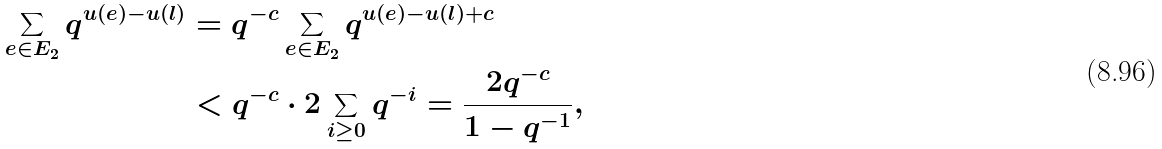Convert formula to latex. <formula><loc_0><loc_0><loc_500><loc_500>\sum _ { e \in E _ { 2 } } q ^ { u ( e ) - u ( l ) } & = q ^ { - c } \sum _ { e \in E _ { 2 } } q ^ { u ( e ) - u ( l ) + c } \\ & < q ^ { - c } \cdot 2 \sum _ { i \geq 0 } q ^ { - i } = \frac { 2 q ^ { - c } } { 1 - q ^ { - 1 } } ,</formula> 